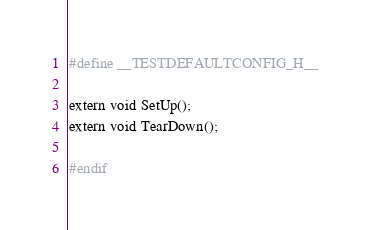Convert code to text. <code><loc_0><loc_0><loc_500><loc_500><_C_>#define __TESTDEFAULTCONFIG_H__

extern void SetUp();
extern void TearDown();

#endif</code> 